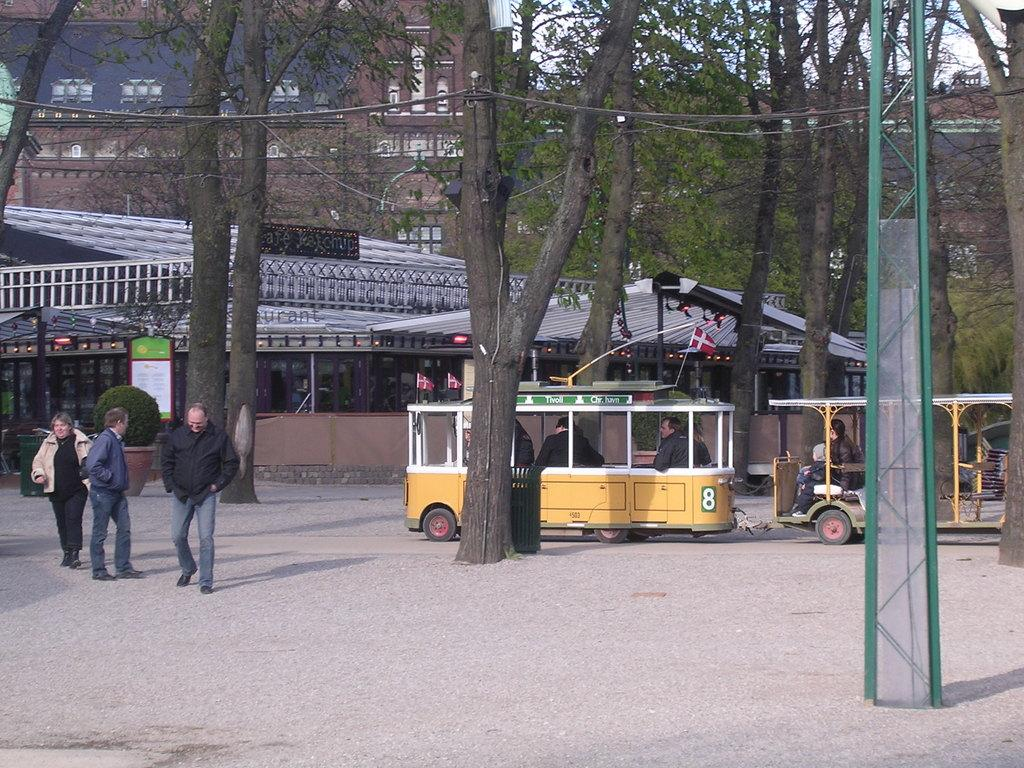<image>
Share a concise interpretation of the image provided. A group of people are riding in a small trolley that says Tivoll on top. 